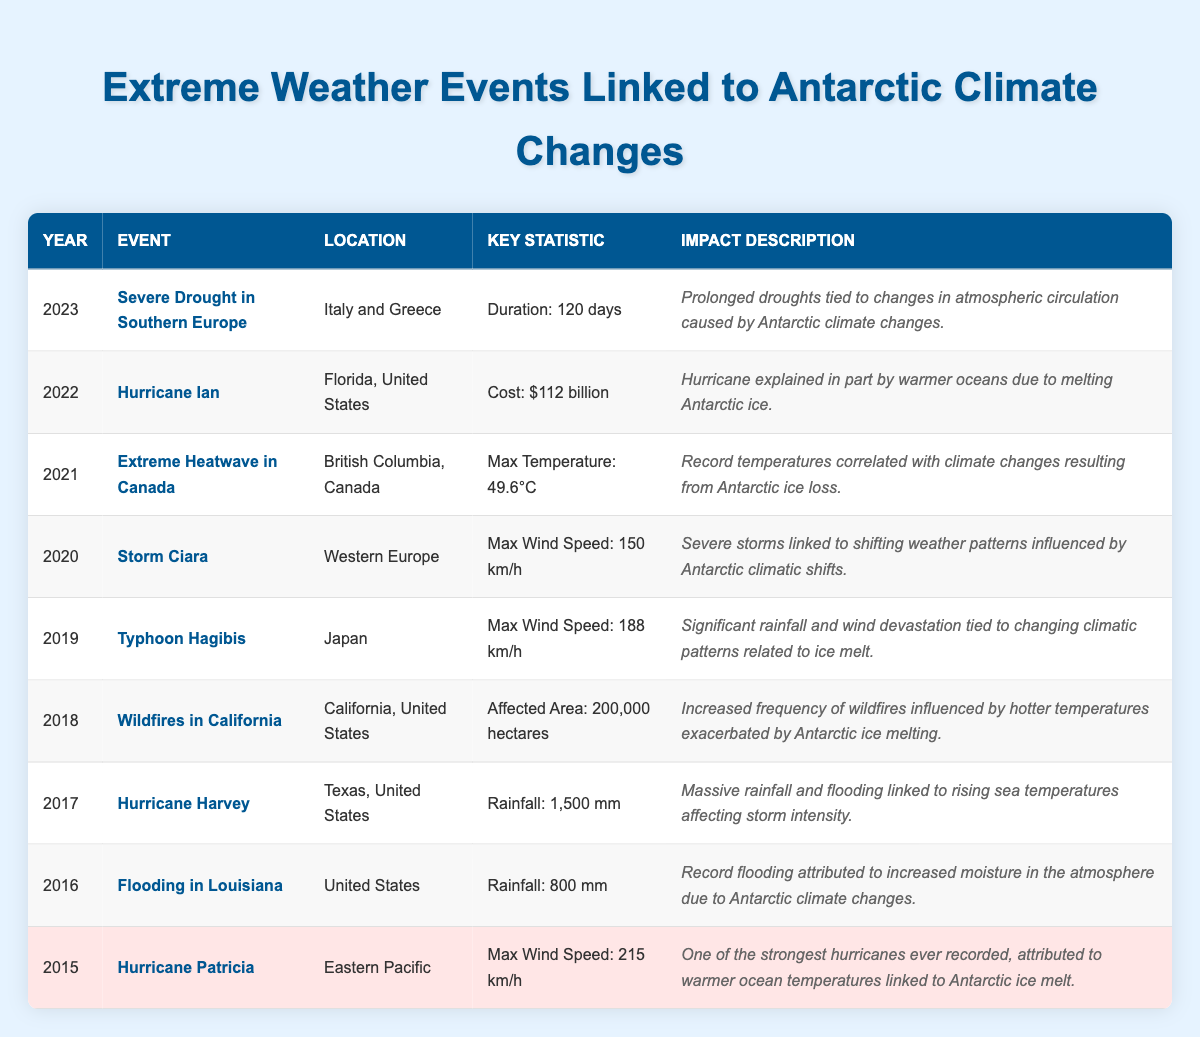What year did Hurricane Harvey occur? Hurricane Harvey is listed in the table under the year 2017.
Answer: 2017 What was the maximum wind speed of Hurricane Patricia? Hurricane Patricia has a maximum wind speed of 215 km/h indicated in the respective row.
Answer: 215 km/h How many days did the severe drought in Southern Europe last? The table specifies that the duration of the severe drought in Southern Europe in 2023 was 120 days.
Answer: 120 days Was the rainfall during Hurricane Harvey higher than during the flooding in Louisiana? Hurricane Harvey had rainfall of 1500 mm while the flooding in Louisiana had 800 mm. Since 1500 mm is greater than 800 mm, the statement is true.
Answer: Yes What is the total rainfall amount recorded for the events in 2016 and 2017? The rainfall in 2016 was 800 mm for Louisiana and 1500 mm for Hurricane Harvey in 2017. Adding these gives 800 + 1500 = 2300 mm.
Answer: 2300 mm Did extreme weather events linked to Antarctic climate changes occur in more than six years from 2015 to 2023? The table includes extreme weather events for each year from 2015 to 2023, totaling 9 years of data, which is more than six. Thus, the statement is true.
Answer: Yes What was the monetary cost estimation for Hurricane Ian? The table states that Hurricane Ian had an estimated cost of 112 billion USD.
Answer: $112 billion Which event in the table had the largest affected area and what was that area? The event with the largest affected area is the wildfires in California in 2018, which affected an area of 200,000 hectares.
Answer: 200,000 hectares What is the difference in maximum wind speeds between Hurricane Patricia and Typhoon Hagibis? The maximum wind speed for Hurricane Patricia is 215 km/h and for Typhoon Hagibis is 188 km/h. The difference is calculated as 215 - 188 = 27 km/h.
Answer: 27 km/h 